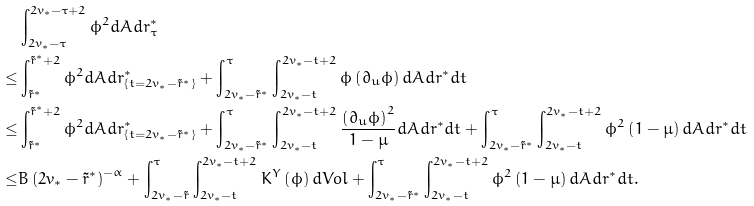Convert formula to latex. <formula><loc_0><loc_0><loc_500><loc_500>& \int _ { 2 v _ { * } - \tau } ^ { 2 v _ { * } - \tau + 2 } \phi ^ { 2 } d A d r ^ { * } _ { \tau } \\ \leq & \int _ { \tilde { r } ^ { * } } ^ { \tilde { r } ^ { * } + 2 } \phi ^ { 2 } d A d r ^ { * } _ { \{ t = 2 v _ { * } - \tilde { r } ^ { * } \} } + \int _ { 2 v _ { * } - \tilde { r } ^ { * } } ^ { \tau } \int _ { 2 v _ { * } - t } ^ { 2 v _ { * } - t + 2 } \phi \left ( \partial _ { u } \phi \right ) d A d r ^ { * } d t \\ \leq & \int _ { \tilde { r } ^ { * } } ^ { \tilde { r } ^ { * } + 2 } \phi ^ { 2 } d A d r ^ { * } _ { \{ t = 2 v _ { * } - \tilde { r } ^ { * } \} } + \int _ { 2 v _ { * } - \tilde { r } ^ { * } } ^ { \tau } \int _ { 2 v _ { * } - t } ^ { 2 v _ { * } - t + 2 } \frac { \left ( \partial _ { u } \phi \right ) ^ { 2 } } { 1 - \mu } d A d r ^ { * } d t + \int _ { 2 v _ { * } - \tilde { r } ^ { * } } ^ { \tau } \int _ { 2 v _ { * } - t } ^ { 2 v _ { * } - t + 2 } \phi ^ { 2 } \left ( 1 - \mu \right ) d A d r ^ { * } d t \\ \leq & B \left ( 2 v _ { * } - \tilde { r } ^ { * } \right ) ^ { - \alpha } + \int _ { 2 v _ { * } - \tilde { r } } ^ { \tau } \int _ { 2 v _ { * } - t } ^ { 2 v _ { * } - t + 2 } K ^ { Y } \left ( \phi \right ) d V o l + \int _ { 2 v _ { * } - \tilde { r } ^ { * } } ^ { \tau } \int _ { 2 v _ { * } - t } ^ { 2 v _ { * } - t + 2 } \phi ^ { 2 } \left ( 1 - \mu \right ) d A d r ^ { * } d t .</formula> 